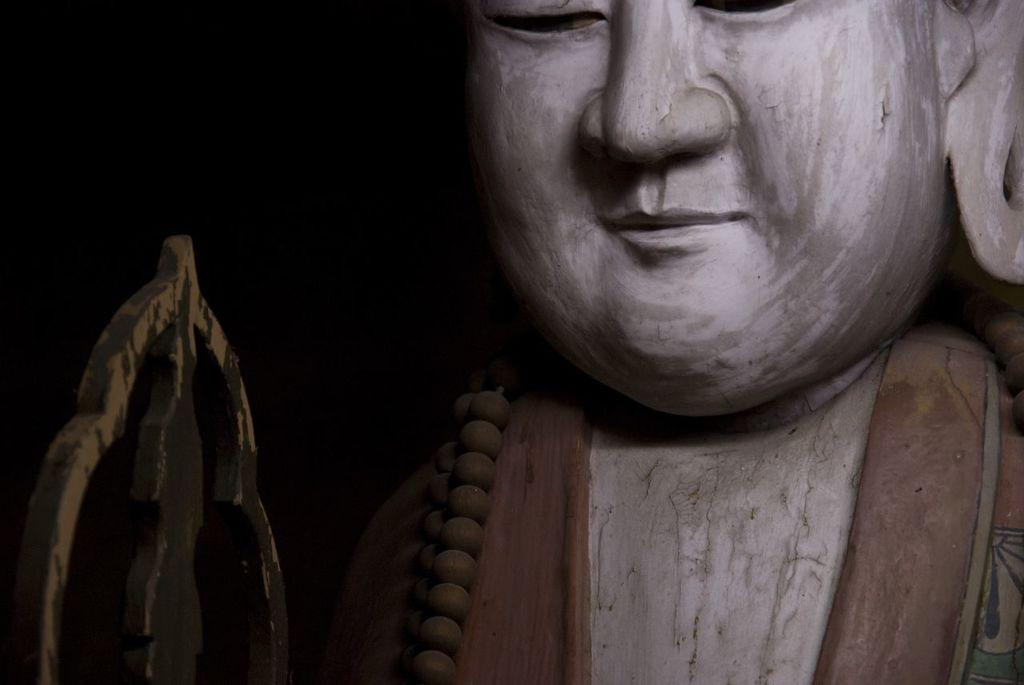What is the main subject in the image? There is a statue in the image. What type of jam is being spread on the bike in the image? There is no bike or jam present in the image; it only features a statue. 